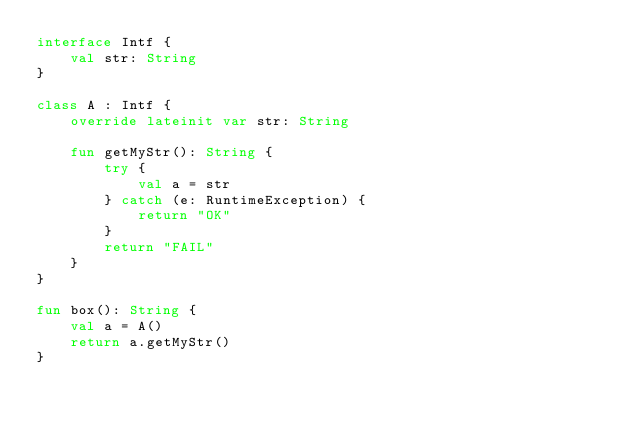<code> <loc_0><loc_0><loc_500><loc_500><_Kotlin_>interface Intf {
    val str: String
}

class A : Intf {
    override lateinit var str: String

    fun getMyStr(): String {
        try {
            val a = str
        } catch (e: RuntimeException) {
            return "OK"
        }
        return "FAIL"
    }
}

fun box(): String {
    val a = A()
    return a.getMyStr()
}</code> 